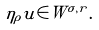Convert formula to latex. <formula><loc_0><loc_0><loc_500><loc_500>\eta _ { \rho } u \in W ^ { \sigma , r } .</formula> 